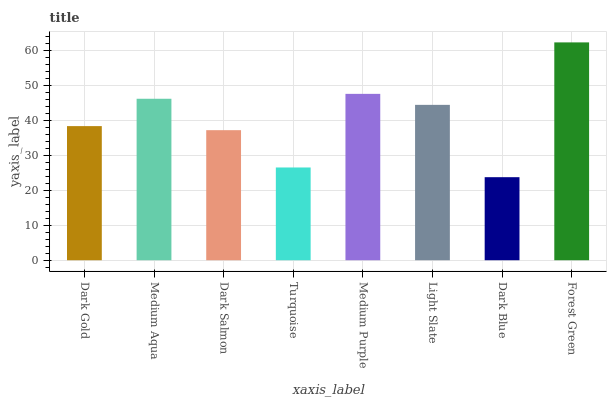Is Medium Aqua the minimum?
Answer yes or no. No. Is Medium Aqua the maximum?
Answer yes or no. No. Is Medium Aqua greater than Dark Gold?
Answer yes or no. Yes. Is Dark Gold less than Medium Aqua?
Answer yes or no. Yes. Is Dark Gold greater than Medium Aqua?
Answer yes or no. No. Is Medium Aqua less than Dark Gold?
Answer yes or no. No. Is Light Slate the high median?
Answer yes or no. Yes. Is Dark Gold the low median?
Answer yes or no. Yes. Is Medium Purple the high median?
Answer yes or no. No. Is Medium Purple the low median?
Answer yes or no. No. 